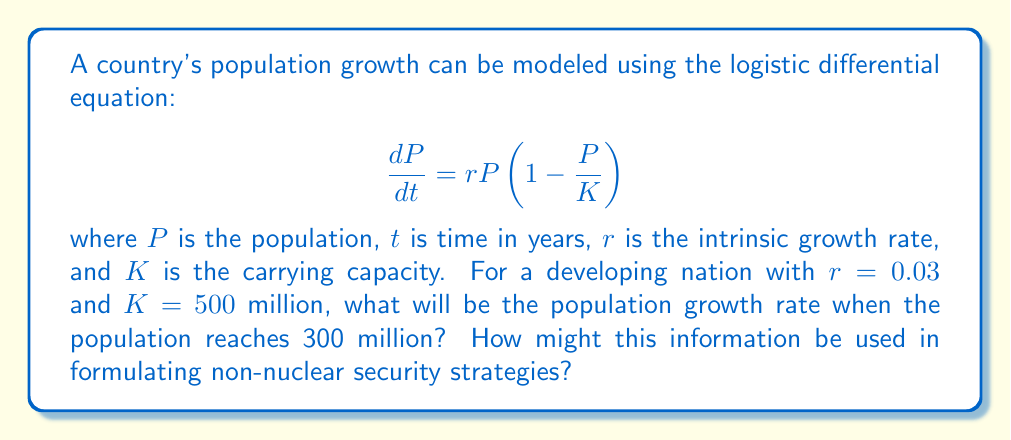Can you solve this math problem? To solve this problem, we need to use the given logistic differential equation and the provided values. Let's approach this step-by-step:

1) We are given:
   $r = 0.03$ (intrinsic growth rate)
   $K = 500$ million (carrying capacity)
   $P = 300$ million (current population)

2) The logistic differential equation is:

   $$\frac{dP}{dt} = rP(1 - \frac{P}{K})$$

3) We need to find $\frac{dP}{dt}$ when $P = 300$ million. Let's substitute the values:

   $$\frac{dP}{dt} = 0.03 \cdot 300(1 - \frac{300}{500})$$

4) Simplify:
   $$\frac{dP}{dt} = 9(1 - 0.6)$$
   $$\frac{dP}{dt} = 9(0.4)$$
   $$\frac{dP}{dt} = 3.6$$

5) Therefore, when the population reaches 300 million, it will be growing at a rate of 3.6 million people per year.

This information can be crucial for non-nuclear security strategies. Understanding population growth rates helps in:
- Projecting future resource needs and potential scarcities
- Anticipating demographic shifts that could impact social stability
- Planning for economic development and job creation
- Assessing potential migration pressures
- Developing sustainable urban planning and infrastructure strategies

By addressing these factors proactively, nations can mitigate potential sources of conflict and instability without relying on nuclear deterrence.
Answer: The population growth rate when the population reaches 300 million will be 3.6 million people per year. 